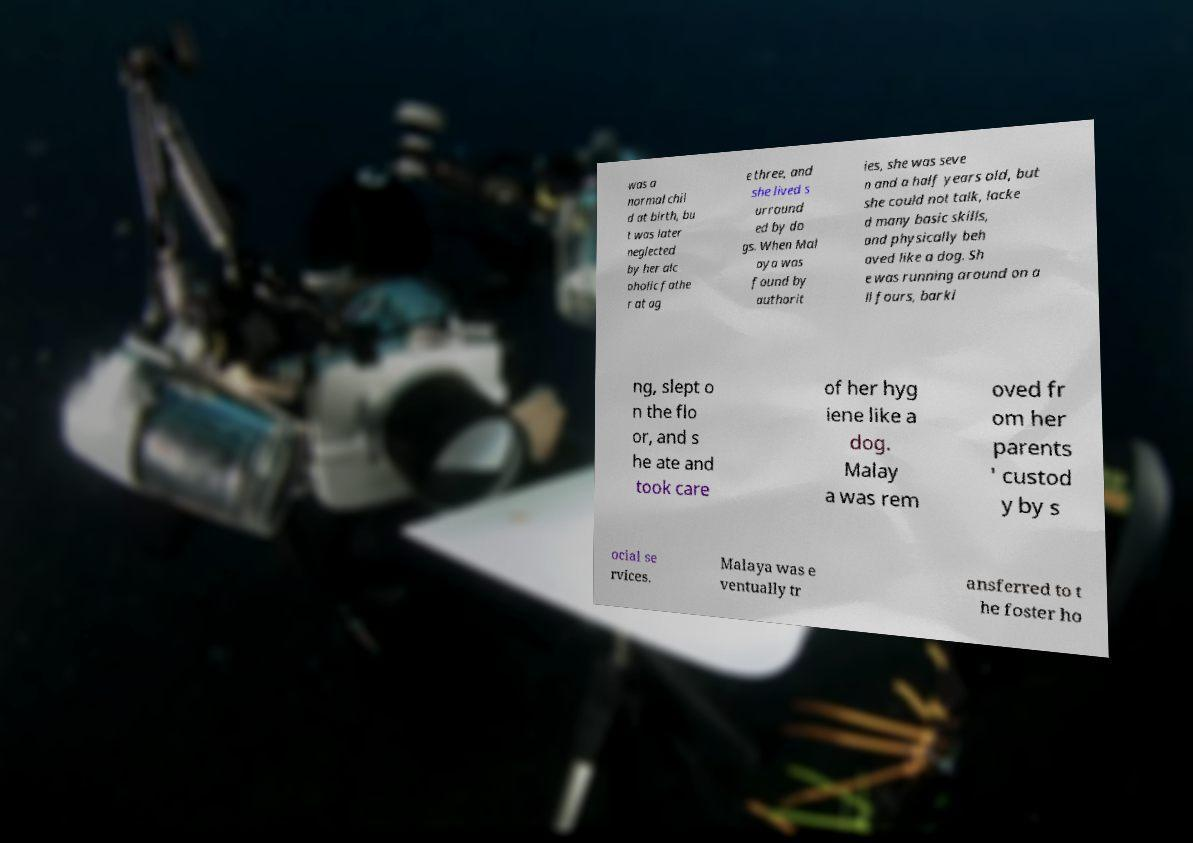There's text embedded in this image that I need extracted. Can you transcribe it verbatim? was a normal chil d at birth, bu t was later neglected by her alc oholic fathe r at ag e three, and she lived s urround ed by do gs. When Mal aya was found by authorit ies, she was seve n and a half years old, but she could not talk, lacke d many basic skills, and physically beh aved like a dog. Sh e was running around on a ll fours, barki ng, slept o n the flo or, and s he ate and took care of her hyg iene like a dog. Malay a was rem oved fr om her parents ' custod y by s ocial se rvices. Malaya was e ventually tr ansferred to t he foster ho 